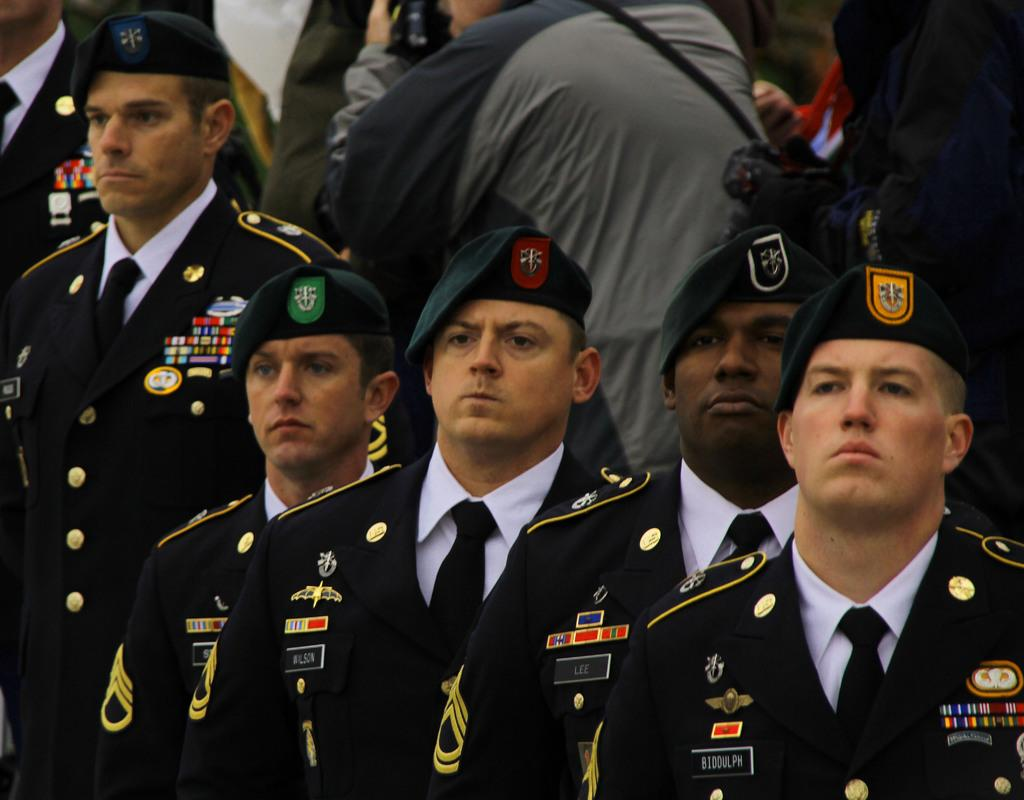Who can be seen in the image? There are people in the image. What are some of the people wearing? Some of the people are wearing uniforms and hats. What type of room can be seen in the background of the image? There is no room visible in the image; it only shows people wearing uniforms and hats. 